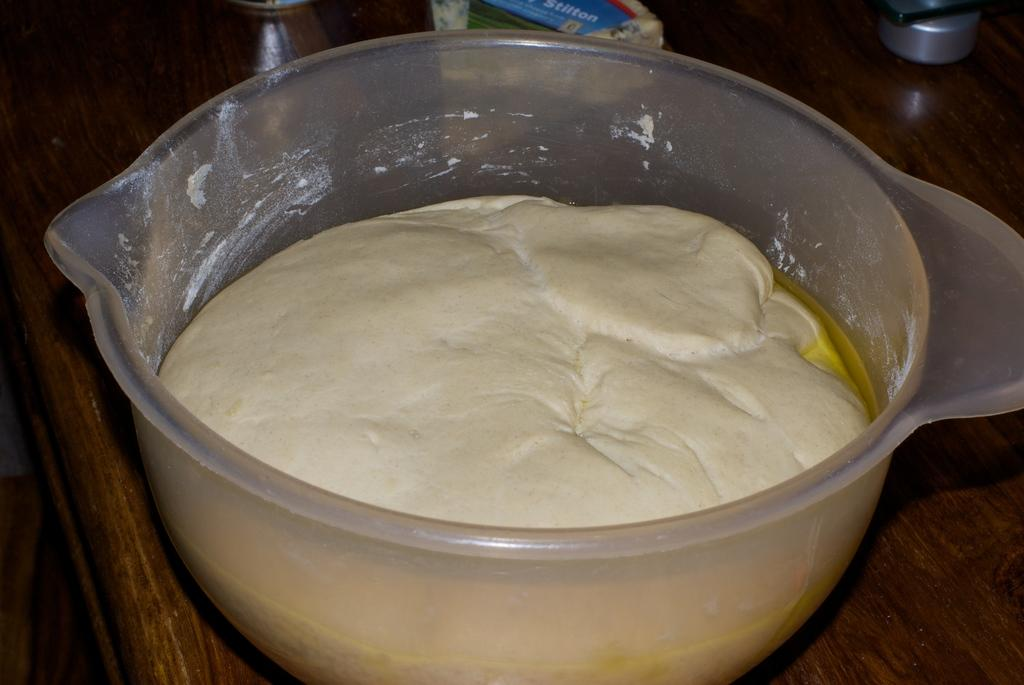What ingredients are combined in the image? There is flour mixed with oil and water in the image. What color is the bowl containing the mixture? The mixture is placed in a white color bowl. On what surface is the bowl resting? The bowl is placed on a brown color table. What type of religion is being practiced in the image? There is no indication of any religious practice in the image; it shows a mixture of flour, oil, and water in a bowl on a table. 